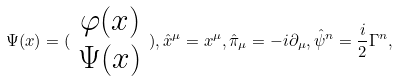Convert formula to latex. <formula><loc_0><loc_0><loc_500><loc_500>\Psi ( x ) = ( \begin{array} { c } \varphi ( x ) \\ \Psi ( x ) \end{array} ) , \hat { x } ^ { \mu } = x ^ { \mu } , \hat { \pi } _ { \mu } = - i \partial _ { \mu } , \hat { \psi } ^ { n } = \frac { i } { 2 } \Gamma ^ { n } ,</formula> 